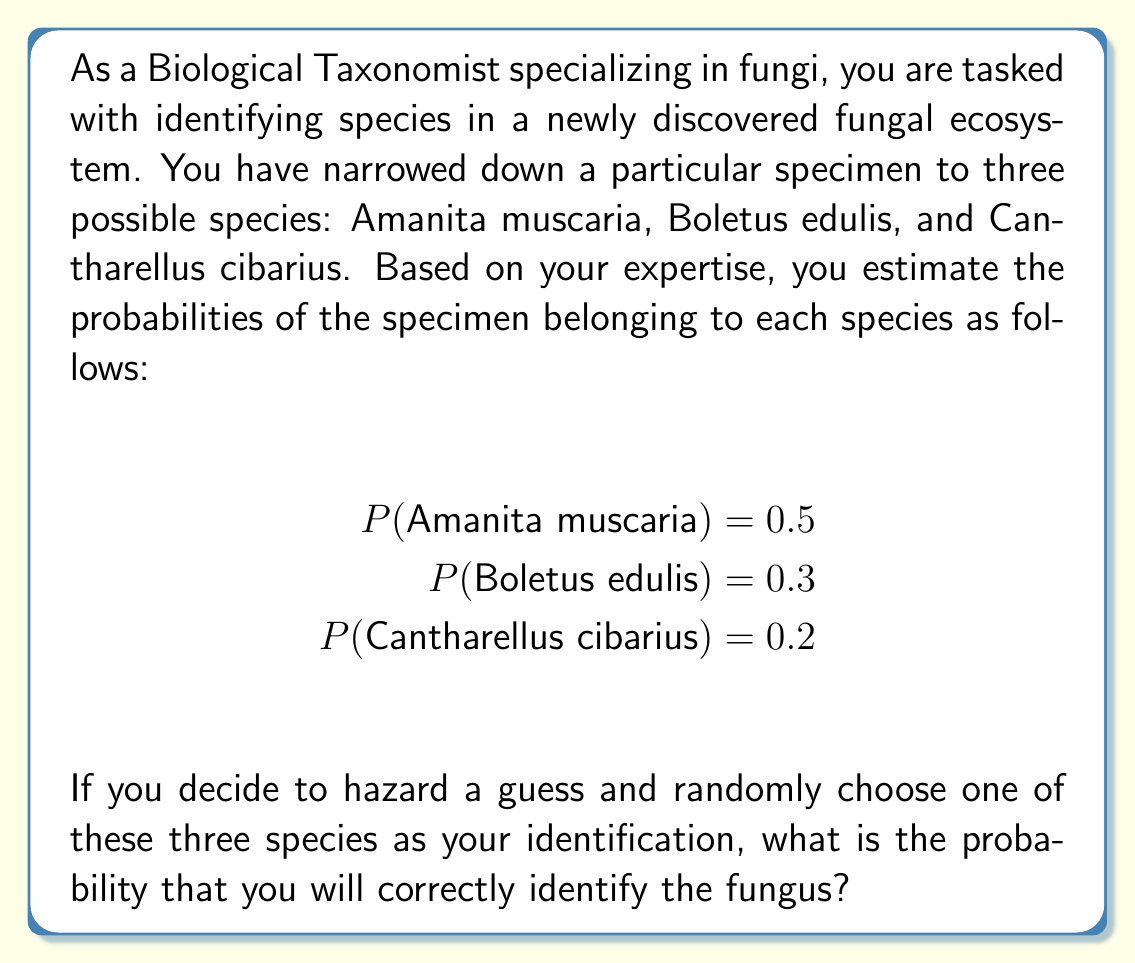Could you help me with this problem? To solve this problem, we need to understand that the probability of correctly identifying the fungus is equal to the sum of the probabilities of each species being correct, given that we choose it.

Let's break it down step by step:

1) The probability of correctly identifying the fungus is the sum of:
   a) The probability of choosing Amanita muscaria AND it being correct
   b) The probability of choosing Boletus edulis AND it being correct
   c) The probability of choosing Cantharellus cibarius AND it being correct

2) For each species:
   - The probability of choosing it is $\frac{1}{3}$ (equal chance for each of the three species)
   - The probability of it being correct is given in the question

3) Let's calculate each probability:

   a) $P(\text{Choose A. muscaria and correct}) = P(\text{Choose A. muscaria}) \times P(\text{A. muscaria is correct})$
      $= \frac{1}{3} \times 0.5 = \frac{1}{6}$

   b) $P(\text{Choose B. edulis and correct}) = P(\text{Choose B. edulis}) \times P(\text{B. edulis is correct})$
      $= \frac{1}{3} \times 0.3 = \frac{1}{10}$

   c) $P(\text{Choose C. cibarius and correct}) = P(\text{Choose C. cibarius}) \times P(\text{C. cibarius is correct})$
      $= \frac{1}{3} \times 0.2 = \frac{1}{15}$

4) The total probability is the sum of these three probabilities:

   $P(\text{Correct identification}) = \frac{1}{6} + \frac{1}{10} + \frac{1}{15}$

5) To add these fractions, we need a common denominator of 30:

   $P(\text{Correct identification}) = \frac{5}{30} + \frac{3}{30} + \frac{2}{30} = \frac{10}{30} = \frac{1}{3}$

Therefore, the probability of correctly identifying the fungus by randomly choosing one of the three species is $\frac{1}{3}$ or approximately 0.3333 or 33.33%.
Answer: $\frac{1}{3}$ or 0.3333 or 33.33% 